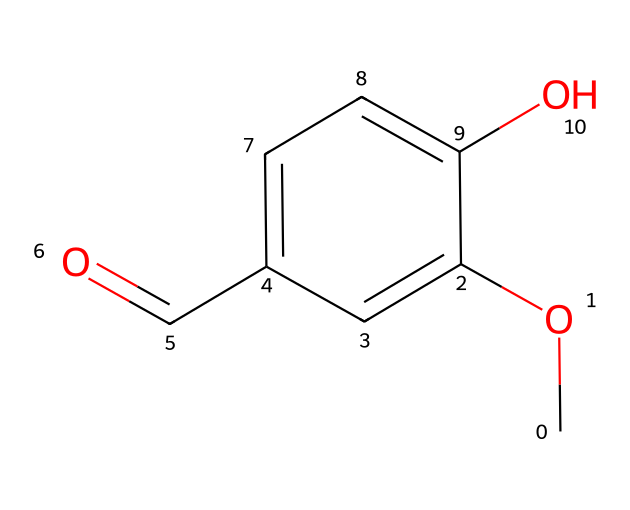What is the functional group present in this compound? The chemical contains a hydroxyl (-OH) group attached to the aromatic ring, which is characteristic of phenolic compounds. The presence of this group indicates that it is indeed a phenol.
Answer: hydroxyl How many carbon atoms are there in the molecule? By analyzing the SMILES notation, we can count the number of carbon atoms present. The entire structure includes six carbon atoms from the aromatic ring and one from the methoxy group (OCH3), totaling seven.
Answer: 7 What type of bond is formed between the carbon atoms and oxygen in the methoxy group? In the methoxy group (OCH3), the bond between the carbon (C) and oxygen (O) is a single bond. This is a typical feature of ethers and alcohols.
Answer: single What is the primary functional group that gives this compound its phenolic properties? The compound’s primary functional group is the hydroxyl (-OH) group. It is the key feature defining phenolic compounds, influencing solubility and reactivity.
Answer: hydroxyl How many hydrogen atoms are in the molecule? The hydrogen atoms can be counted based on the structure described in the SMILES notation. Considering five hydrogen from the aromatic ring and three from the methoxy group, the total is eight hydrogen atoms.
Answer: 8 What structural feature contributes to the molecule's potential reactivity with other substances? The presence of the hydroxyl (-OH) group is significant as it can donate hydrogen ions (protons) and participate in hydrogen bonding, which increases the molecule's reactivity with various substances.
Answer: hydroxyl 